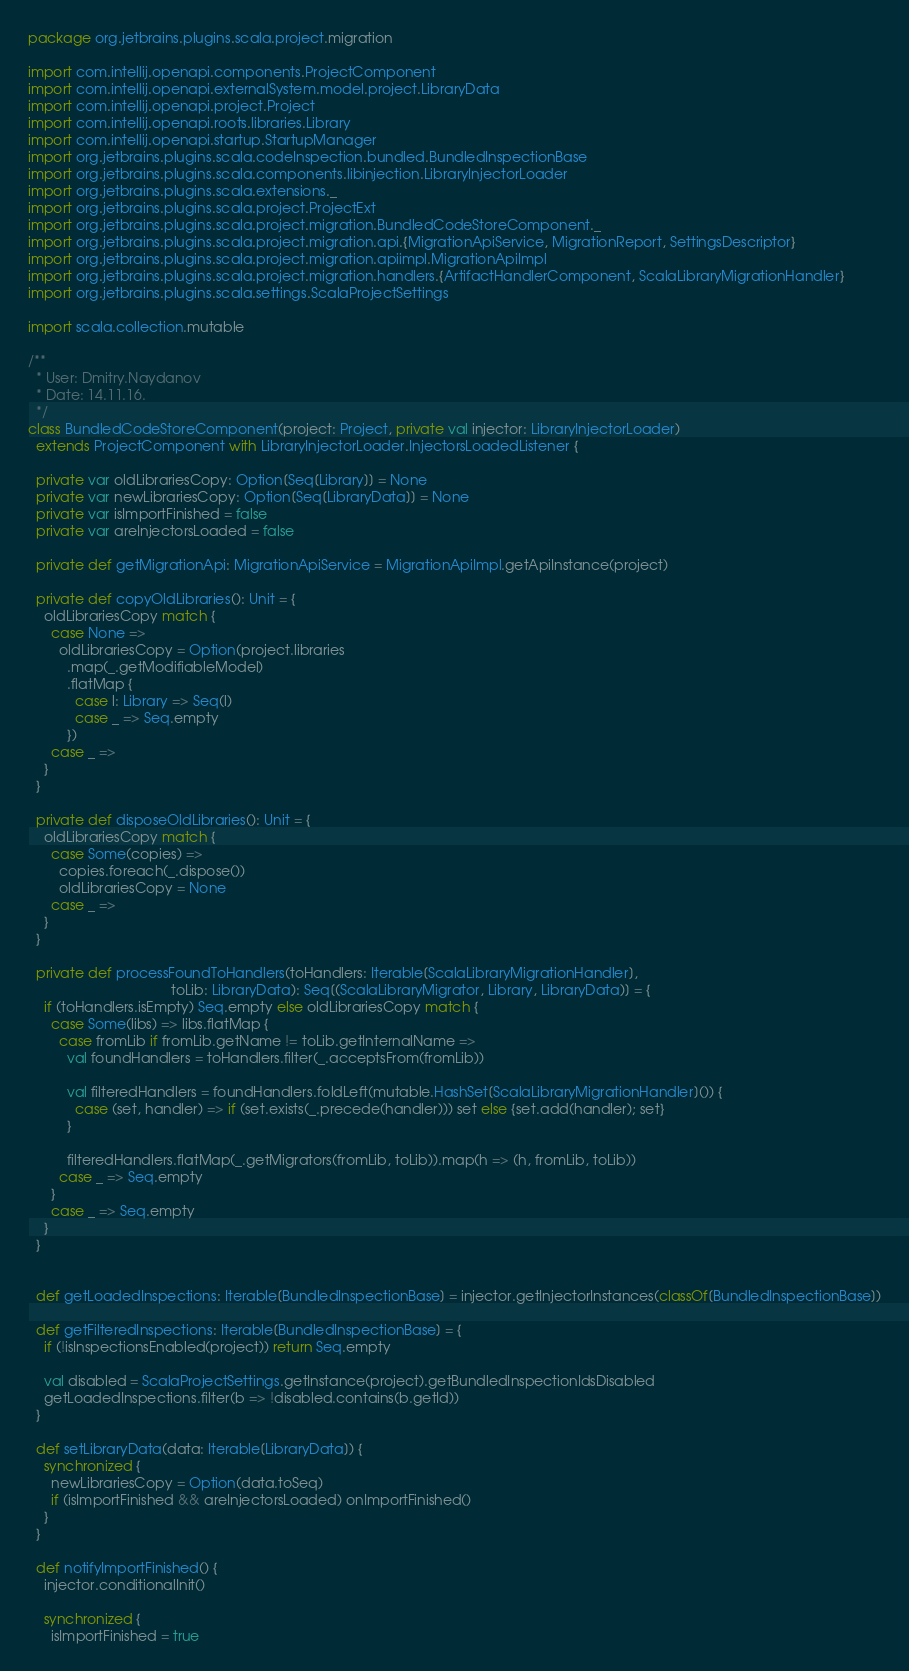Convert code to text. <code><loc_0><loc_0><loc_500><loc_500><_Scala_>package org.jetbrains.plugins.scala.project.migration

import com.intellij.openapi.components.ProjectComponent
import com.intellij.openapi.externalSystem.model.project.LibraryData
import com.intellij.openapi.project.Project
import com.intellij.openapi.roots.libraries.Library
import com.intellij.openapi.startup.StartupManager
import org.jetbrains.plugins.scala.codeInspection.bundled.BundledInspectionBase
import org.jetbrains.plugins.scala.components.libinjection.LibraryInjectorLoader
import org.jetbrains.plugins.scala.extensions._
import org.jetbrains.plugins.scala.project.ProjectExt
import org.jetbrains.plugins.scala.project.migration.BundledCodeStoreComponent._
import org.jetbrains.plugins.scala.project.migration.api.{MigrationApiService, MigrationReport, SettingsDescriptor}
import org.jetbrains.plugins.scala.project.migration.apiimpl.MigrationApiImpl
import org.jetbrains.plugins.scala.project.migration.handlers.{ArtifactHandlerComponent, ScalaLibraryMigrationHandler}
import org.jetbrains.plugins.scala.settings.ScalaProjectSettings

import scala.collection.mutable

/**
  * User: Dmitry.Naydanov
  * Date: 14.11.16.
  */
class BundledCodeStoreComponent(project: Project, private val injector: LibraryInjectorLoader)
  extends ProjectComponent with LibraryInjectorLoader.InjectorsLoadedListener {

  private var oldLibrariesCopy: Option[Seq[Library]] = None
  private var newLibrariesCopy: Option[Seq[LibraryData]] = None
  private var isImportFinished = false
  private var areInjectorsLoaded = false

  private def getMigrationApi: MigrationApiService = MigrationApiImpl.getApiInstance(project)
  
  private def copyOldLibraries(): Unit = {
    oldLibrariesCopy match {
      case None =>
        oldLibrariesCopy = Option(project.libraries
          .map(_.getModifiableModel)
          .flatMap {
            case l: Library => Seq(l)
            case _ => Seq.empty
          })
      case _ =>
    }
  }
  
  private def disposeOldLibraries(): Unit = {
    oldLibrariesCopy match {
      case Some(copies) =>
        copies.foreach(_.dispose())
        oldLibrariesCopy = None
      case _ => 
    }
  }
  
  private def processFoundToHandlers(toHandlers: Iterable[ScalaLibraryMigrationHandler], 
                                     toLib: LibraryData): Seq[(ScalaLibraryMigrator, Library, LibraryData)] = {
    if (toHandlers.isEmpty) Seq.empty else oldLibrariesCopy match {
      case Some(libs) => libs.flatMap {
        case fromLib if fromLib.getName != toLib.getInternalName =>
          val foundHandlers = toHandlers.filter(_.acceptsFrom(fromLib))

          val filteredHandlers = foundHandlers.foldLeft(mutable.HashSet[ScalaLibraryMigrationHandler]()) {
            case (set, handler) => if (set.exists(_.precede(handler))) set else {set.add(handler); set}
          }

          filteredHandlers.flatMap(_.getMigrators(fromLib, toLib)).map(h => (h, fromLib, toLib))
        case _ => Seq.empty
      }
      case _ => Seq.empty
    }
  }
  
  
  def getLoadedInspections: Iterable[BundledInspectionBase] = injector.getInjectorInstances(classOf[BundledInspectionBase])

  def getFilteredInspections: Iterable[BundledInspectionBase] = {
    if (!isInspectionsEnabled(project)) return Seq.empty

    val disabled = ScalaProjectSettings.getInstance(project).getBundledInspectionIdsDisabled
    getLoadedInspections.filter(b => !disabled.contains(b.getId))
  }
  
  def setLibraryData(data: Iterable[LibraryData]) {
    synchronized {
      newLibrariesCopy = Option(data.toSeq)
      if (isImportFinished && areInjectorsLoaded) onImportFinished()
    }
  }
  
  def notifyImportFinished() {
    injector.conditionalInit()
    
    synchronized {
      isImportFinished = true</code> 